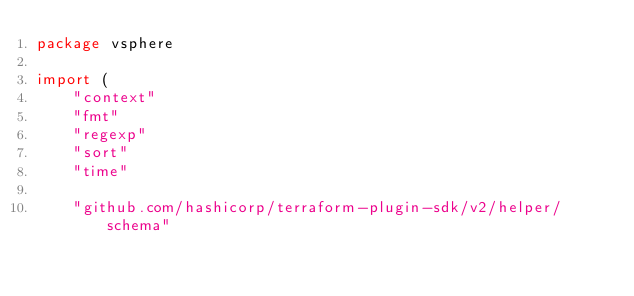<code> <loc_0><loc_0><loc_500><loc_500><_Go_>package vsphere

import (
	"context"
	"fmt"
	"regexp"
	"sort"
	"time"

	"github.com/hashicorp/terraform-plugin-sdk/v2/helper/schema"</code> 